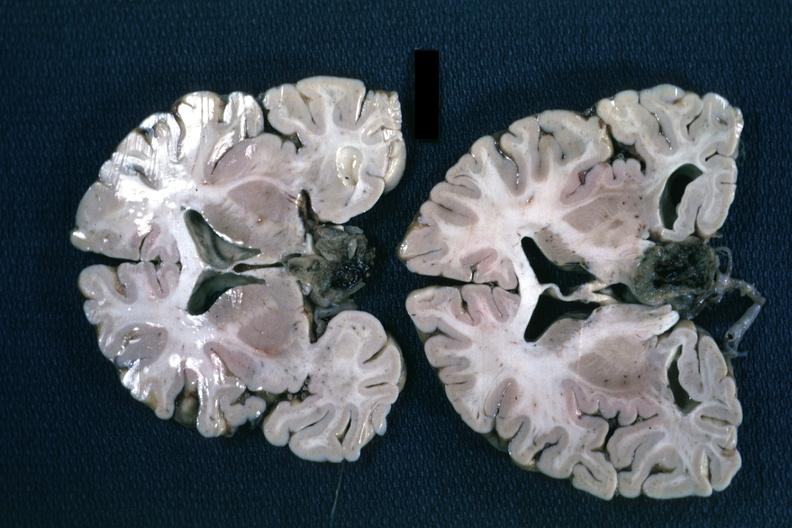what is present?
Answer the question using a single word or phrase. Chromophobe adenoma 